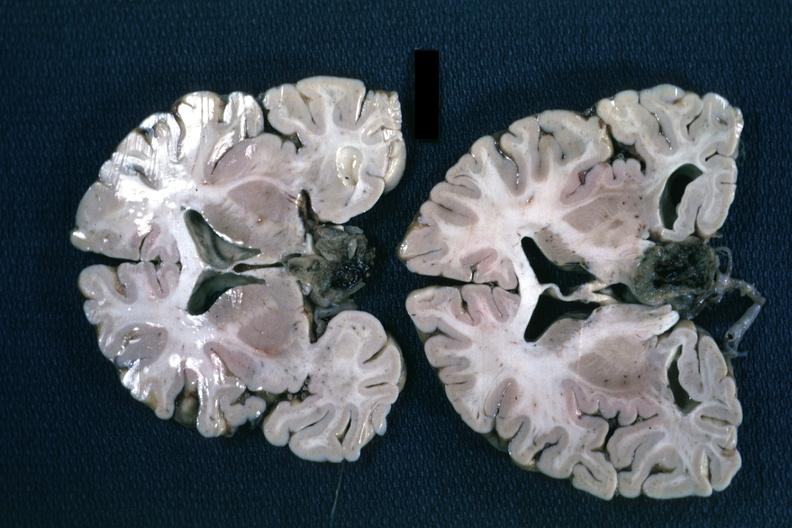what is present?
Answer the question using a single word or phrase. Chromophobe adenoma 